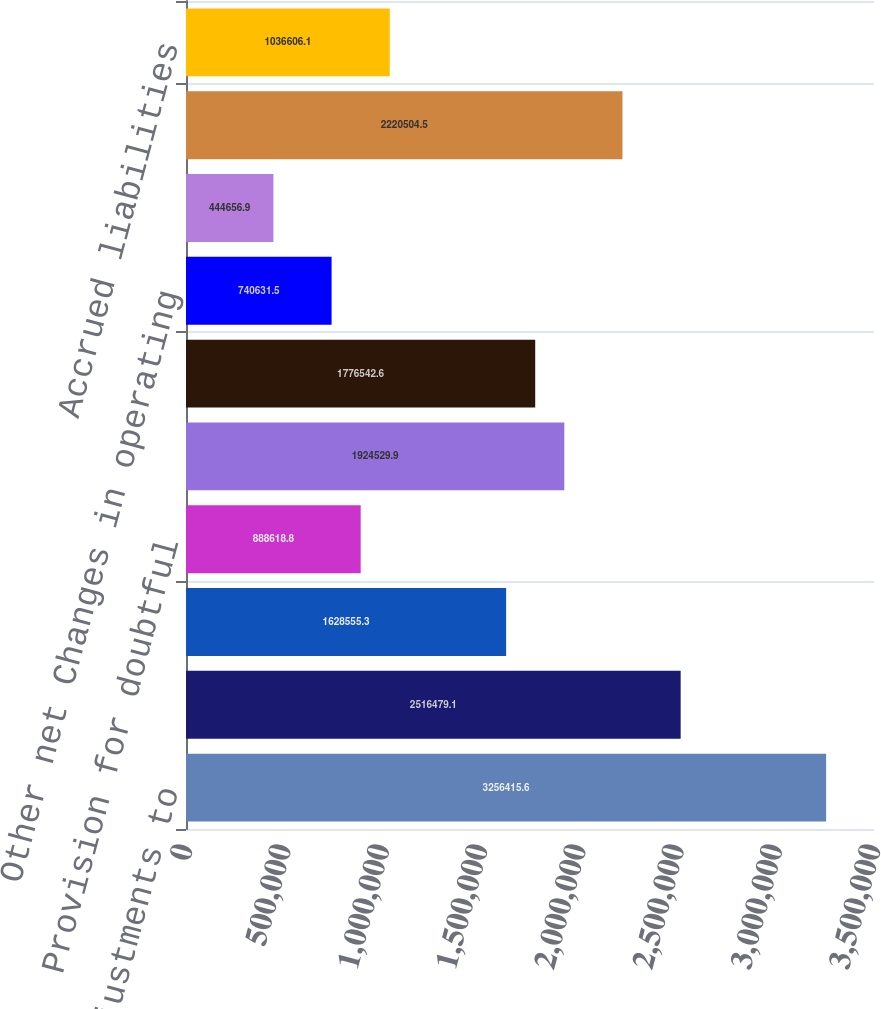Convert chart. <chart><loc_0><loc_0><loc_500><loc_500><bar_chart><fcel>Net income Adjustments to<fcel>Depreciation and amortization<fcel>Stock-based compensation<fcel>Provision for doubtful<fcel>Pension expense (less than) in<fcel>Deferred income taxes Loss on<fcel>Other net Changes in operating<fcel>Accounts payable<fcel>Income taxes<fcel>Accrued liabilities<nl><fcel>3.25642e+06<fcel>2.51648e+06<fcel>1.62856e+06<fcel>888619<fcel>1.92453e+06<fcel>1.77654e+06<fcel>740632<fcel>444657<fcel>2.2205e+06<fcel>1.03661e+06<nl></chart> 